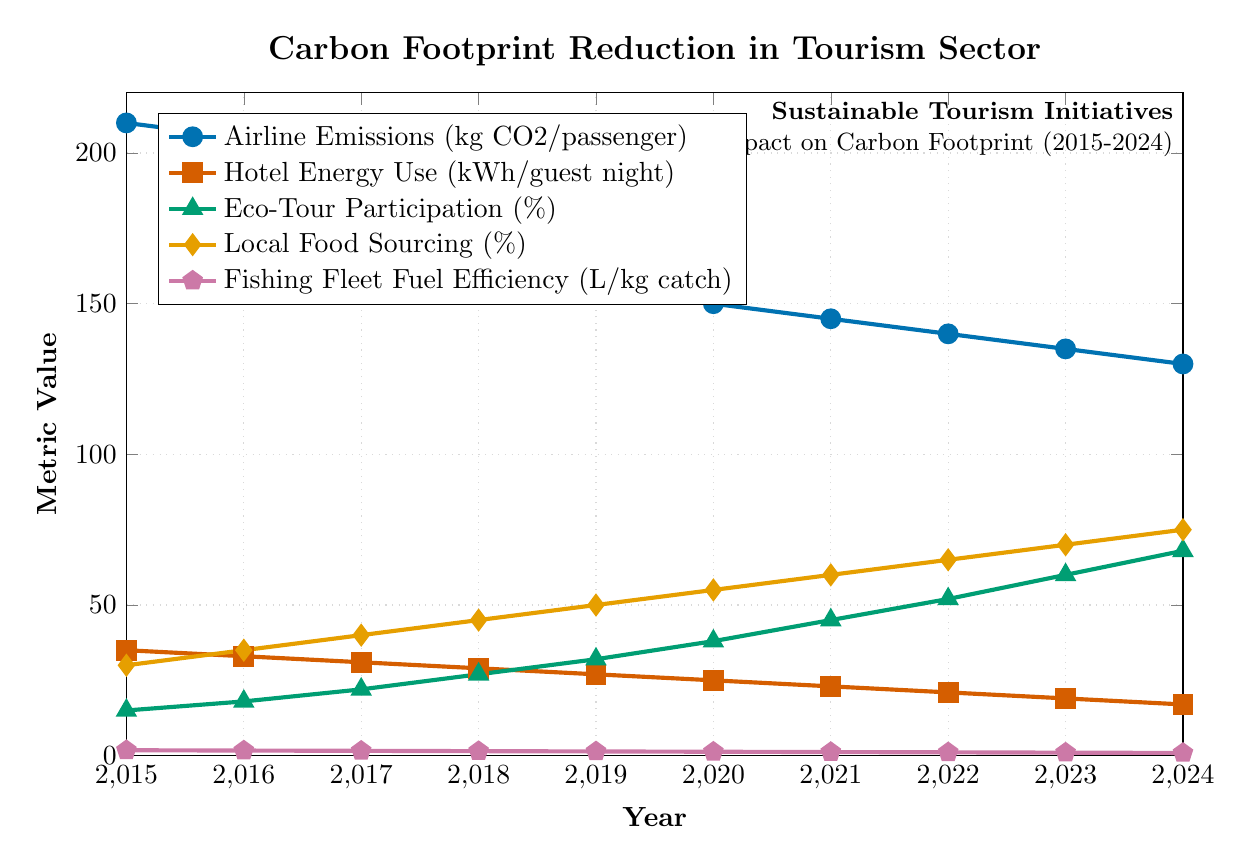What's the general trend of airline emissions from 2015 to 2024? To determine the trend, observe the line representing "Airline Emissions (kg CO2/passenger)" from 2015 to 2024. The general direction of the line is downward, indicating a decrease.
Answer: Downward By how much did hotel energy use decrease from 2015 to 2024? Look at the values for "Hotel Energy Use (kWh/guest night)" in 2015 and 2024. In 2015, it was 35 kWh/guest night, and in 2024, it was 17 kWh/guest night. The decrease is 35 - 17 = 18 kWh/guest night.
Answer: 18 kWh/guest night Which year saw the highest increase in eco-tour participation compared to the previous year? Check the values of "Eco-Tour Participation (%)" for each year and calculate the year-over-year difference. The highest increase occurs between 2023 (60%) and 2024 (68%), which is an increase of 8%.
Answer: 2024 How does local food sourcing in 2024 compare to that in 2015? Examine the values for "Local Food Sourcing (%)" in 2015 and 2024. In 2015, it was 30%, and in 2024, it was 75%. Visually, this shows a significant increase.
Answer: Increased significantly By what percentage did fishing fleet fuel efficiency improve from 2015 to 2024? Look at the values for "Fishing Fleet Fuel Efficiency (L/kg catch)" in 2015 and 2024. Use the formula: (initial value - final value) / initial value * 100%. So, (1.8 - 0.9) / 1.8 * 100% = 50%.
Answer: 50% In which year did all the metrics related to sustainability show improvement compared to the first year (2015)? Compare all metrics for each year against their respective values in 2015. Each metric shows improvement in 2016 and continues improving every year onwards.
Answer: 2016 and onwards What's the difference between the airline emissions and hotel energy use in the year 2020? For 2020, "Airline Emissions" is 150 kg CO2/passenger, and "Hotel Energy Use" is 25 kWh/guest night. The difference is 150 - 25 = 125.
Answer: 125 Which color represents the trend line for local food sourcing in the plot? Observe the legend and match the description "Local Food Sourcing (%)" to the color of the trend line. The color is visually yellowish-orange.
Answer: Yellowish-orange 